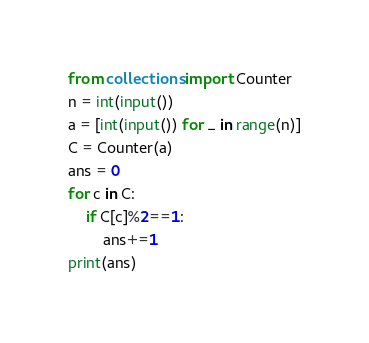Convert code to text. <code><loc_0><loc_0><loc_500><loc_500><_Python_>from collections import Counter
n = int(input())
a = [int(input()) for _ in range(n)]
C = Counter(a)
ans = 0
for c in C:
    if C[c]%2==1:
        ans+=1
print(ans)</code> 